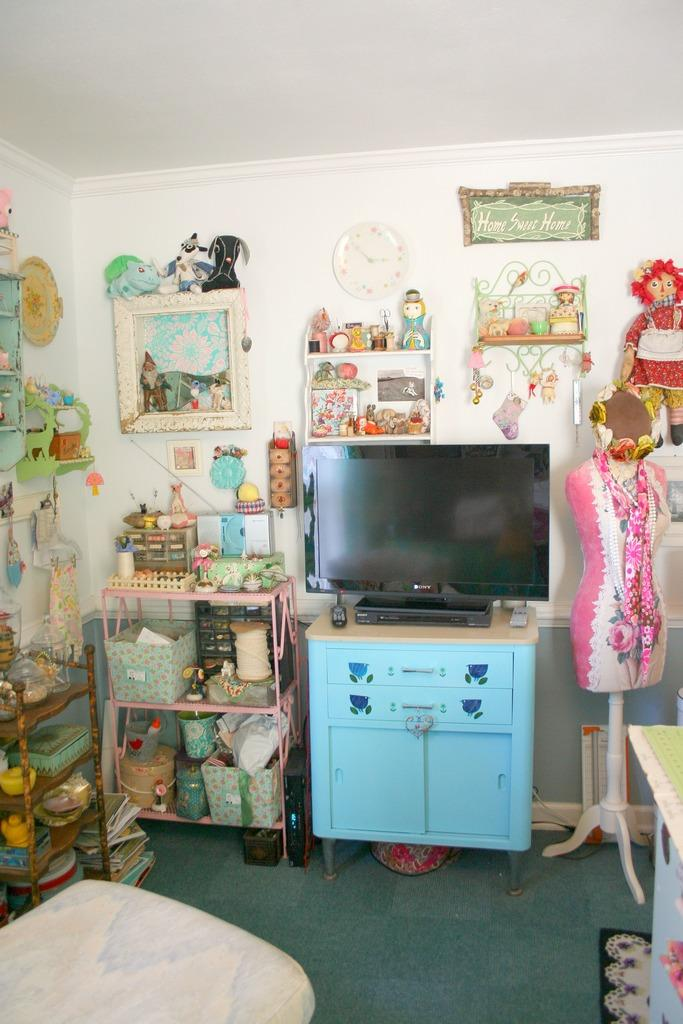<image>
Render a clear and concise summary of the photo. A cluttered bedroom with Home Sweet Home framed on the wall. 